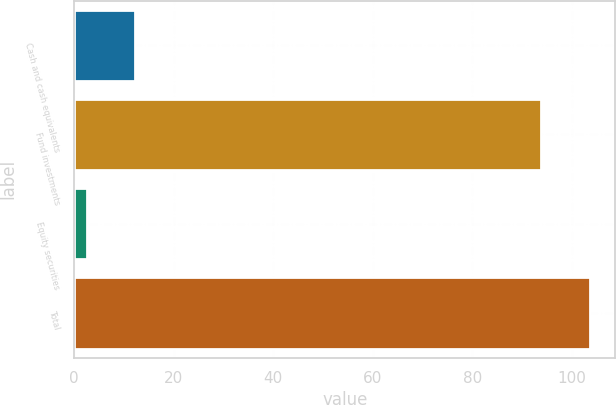<chart> <loc_0><loc_0><loc_500><loc_500><bar_chart><fcel>Cash and cash equivalents<fcel>Fund investments<fcel>Equity securities<fcel>Total<nl><fcel>12.25<fcel>93.8<fcel>2.5<fcel>103.55<nl></chart> 